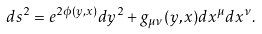<formula> <loc_0><loc_0><loc_500><loc_500>d s ^ { 2 } = e ^ { 2 \phi ( y , x ) } d y ^ { 2 } + g _ { \mu \nu } ( y , x ) d x ^ { \mu } d x ^ { \nu } .</formula> 